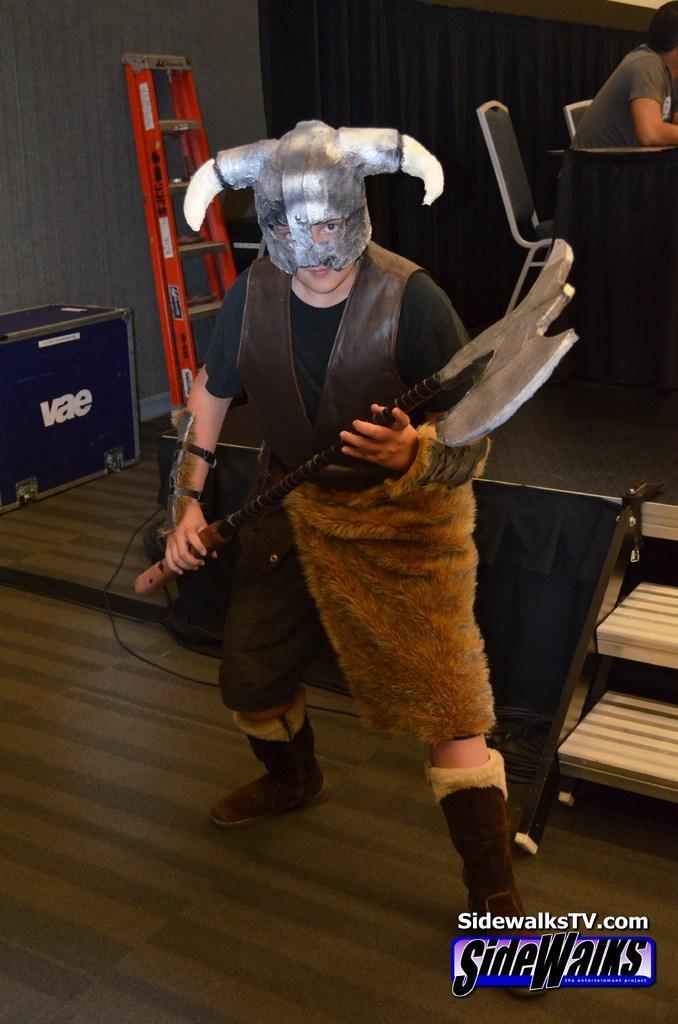Please provide a concise description of this image. In this image there is a person holding an equipment visible on the floor, back side there is a person sitting on chair in front of table, there are some other objects visible. 